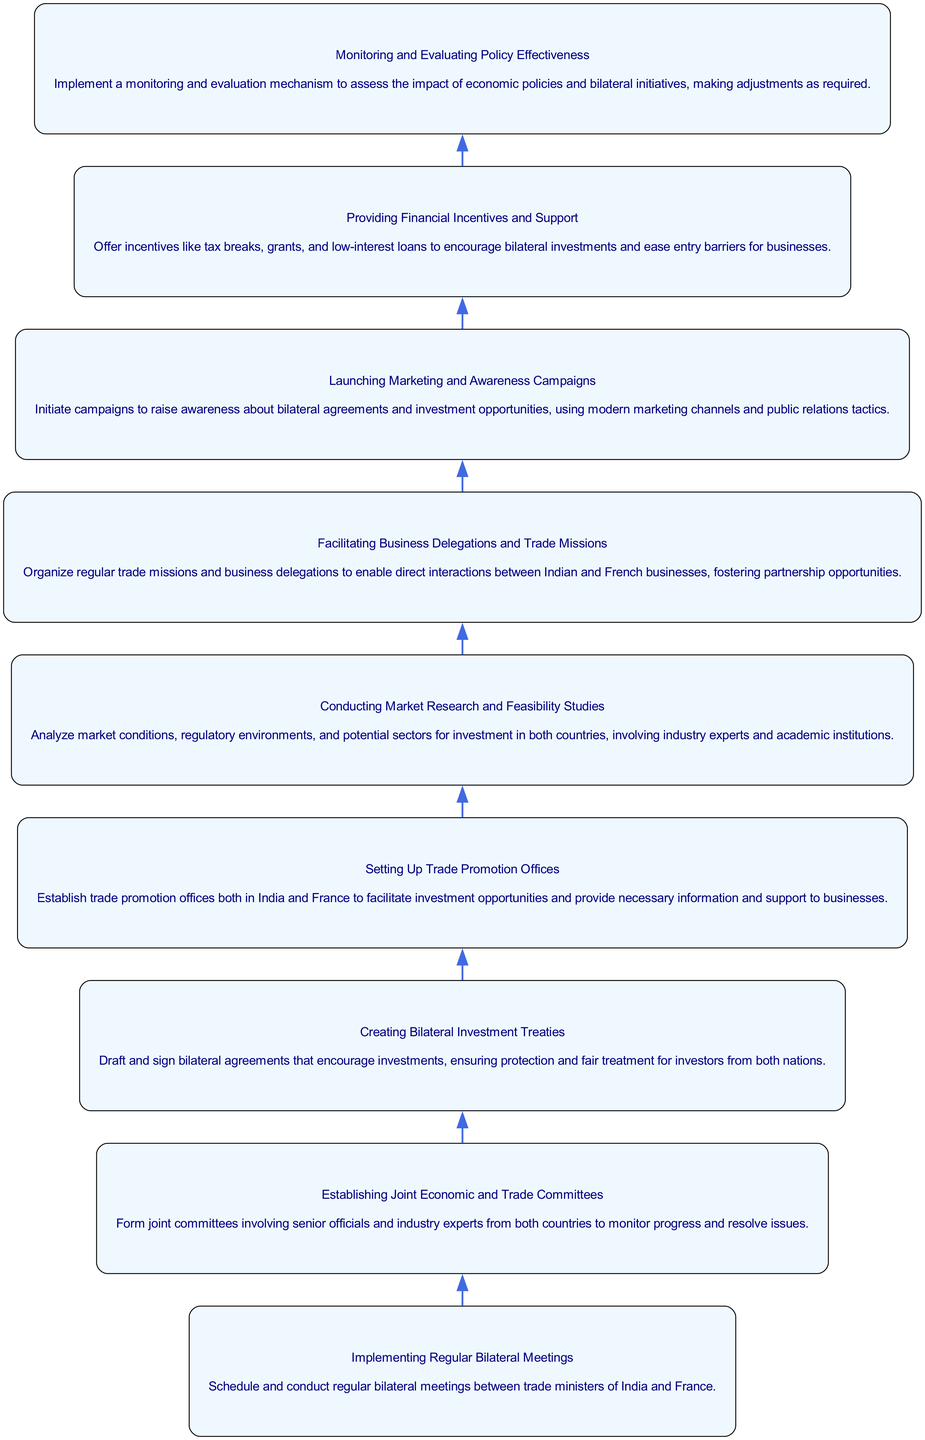What is the first step in the framework? The first step listed at the bottom of the flow chart is "Implementing Regular Bilateral Meetings", which involves scheduling bilateral meetings between trade ministers of India and France.
Answer: Implementing Regular Bilateral Meetings How many total steps are in the framework? Counting the nodes in the provided diagram, there are a total of 9 steps including the last step which is "Monitoring and Evaluating Policy Effectiveness."
Answer: 9 What step follows "Starting Up Trade Promotion Offices"? In the flow chart, "Starting Up Trade Promotion Offices" is followed by "Conducting Market Research and Feasibility Studies."
Answer: Conducting Market Research and Feasibility Studies Which step is responsible for exploring market conditions? The step "Conducting Market Research and Feasibility Studies" is responsible for analyzing market conditions and other relevant factors for investments.
Answer: Conducting Market Research and Feasibility Studies Which steps involve direct interactions between businesses? The step "Facilitating Business Delegations and Trade Missions" is focused on organizing direct interactions between Indian and French businesses.
Answer: Facilitating Business Delegations and Trade Missions What type of financial support is mentioned in the framework? The framework mentions providing incentives such as tax breaks, grants, and low-interest loans as financial support to promote bilateral investments.
Answer: Tax breaks, grants, low-interest loans What is the last node described in the framework? The last node at the top of the flow chart is "Monitoring and Evaluating Policy Effectiveness," which focuses on assessing the impact of the implemented policies.
Answer: Monitoring and Evaluating Policy Effectiveness Which two steps are interconnected last? The last two interconnected steps before monitoring are "Providing Financial Incentives and Support" and "Monitoring and Evaluating Policy Effectiveness."
Answer: Providing Financial Incentives and Support and Monitoring and Evaluating Policy Effectiveness How does the flow of the diagram move? The flow of the diagram moves upwards from "Implementing Regular Bilateral Meetings" at the bottom to "Monitoring and Evaluating Policy Effectiveness" at the top.
Answer: Upwards 